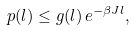<formula> <loc_0><loc_0><loc_500><loc_500>p ( l ) \leq g ( l ) \, e ^ { - \beta J l } ,</formula> 